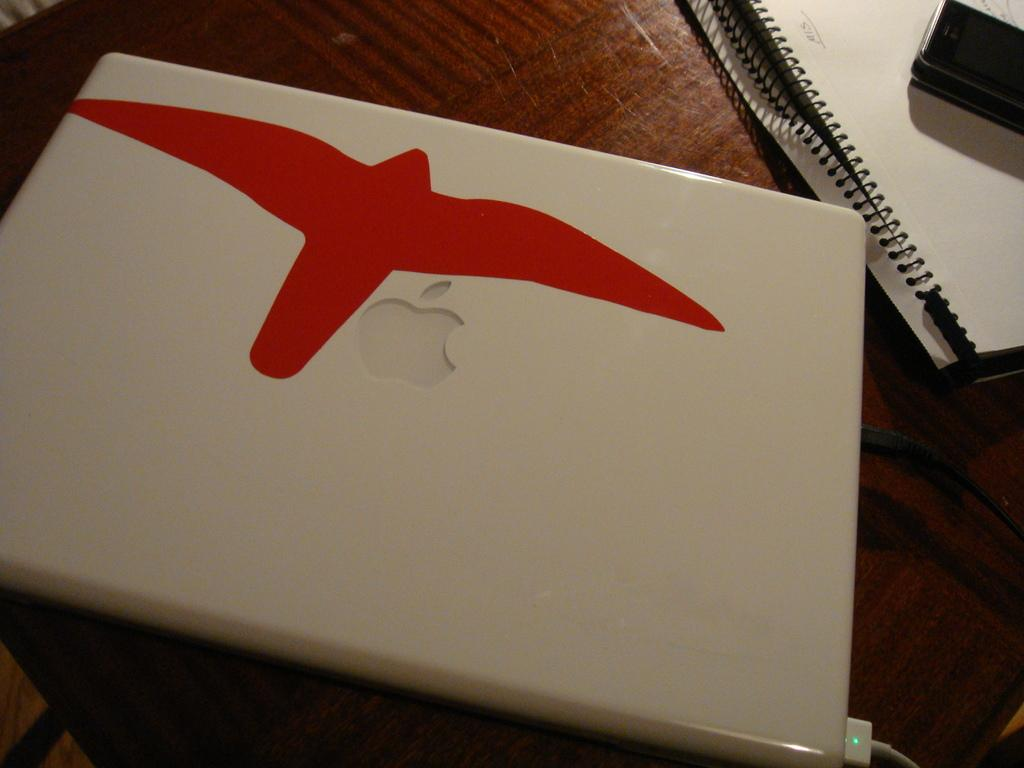What type of surface is visible in the image? There is a wooden surface in the image. What object is placed on the wooden surface? There is a book on the wooden surface. What is on top of the book? There is a device on the book. What electronic device is present in the image? There is a laptop on the wooden surface. What color is the grape that is being folded in the image? There is no grape present in the image, nor is there any folding activity. 